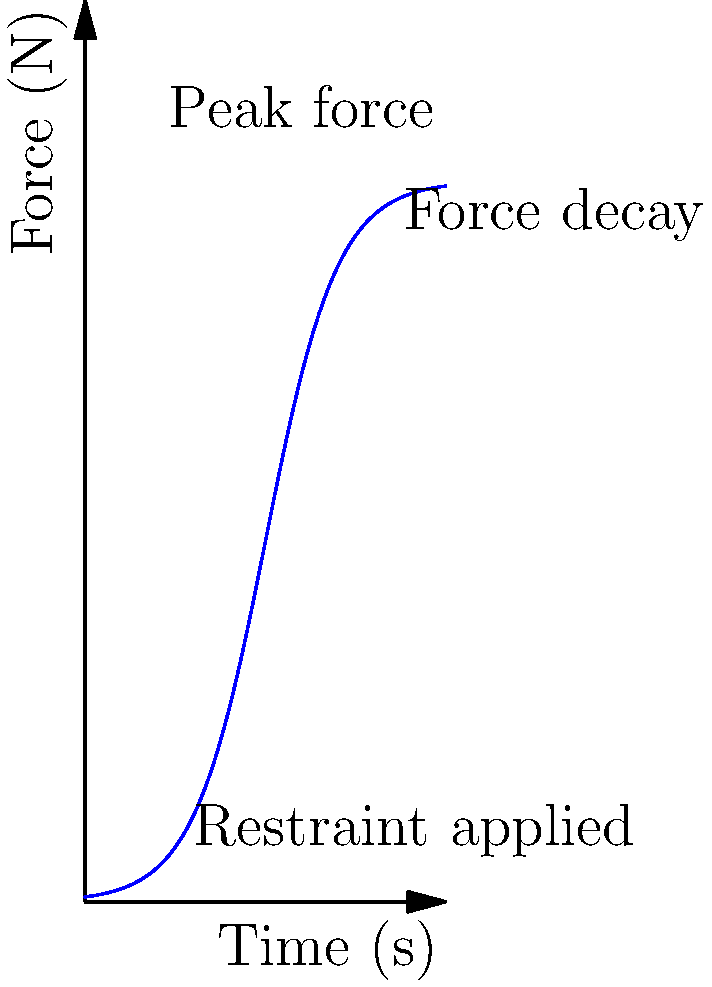In the context of police restraints, the graph shows the typical force profile over time during a restraint application. What biomechanical principle explains the initial rapid increase in force followed by a plateau? To understand the biomechanical principle behind the force profile in police restraints, let's analyze the graph step-by-step:

1. Initial rapid increase:
   - This represents the application of the restraint.
   - The force rises quickly as the officer applies pressure.
   - Biomechanically, this relates to the viscoelastic properties of human tissue.

2. Plateau phase:
   - The force reaches a maximum and then stabilizes.
   - This plateau is explained by the stress-relaxation phenomenon.

3. Stress-relaxation principle:
   - When a constant deformation is applied to viscoelastic tissue (like muscles and ligaments), the initial stress (force) is high.
   - Over time, the tissue reorganizes its internal structure to accommodate the deformation.
   - This leads to a decrease in the stress (force) required to maintain the same deformation.

4. Mathematical representation:
   - The stress-relaxation can be modeled using the equation:
     $$F(t) = F_∞ + (F_0 - F_∞)e^{-t/τ}$$
   Where:
   $F(t)$ is the force at time $t$
   $F_∞$ is the equilibrium force
   $F_0$ is the initial force
   $τ$ is the relaxation time constant

5. Application to restraints:
   - In police restraints, the initial force application causes rapid tissue deformation.
   - As the restraint is held constant, the tissue undergoes stress-relaxation.
   - This results in the force plateau observed in the graph.

6. Human rights implications:
   - Understanding this principle is crucial for developing safer restraint techniques.
   - It highlights the importance of monitoring applied force over time to prevent injury.
Answer: Stress-relaxation of viscoelastic tissue 